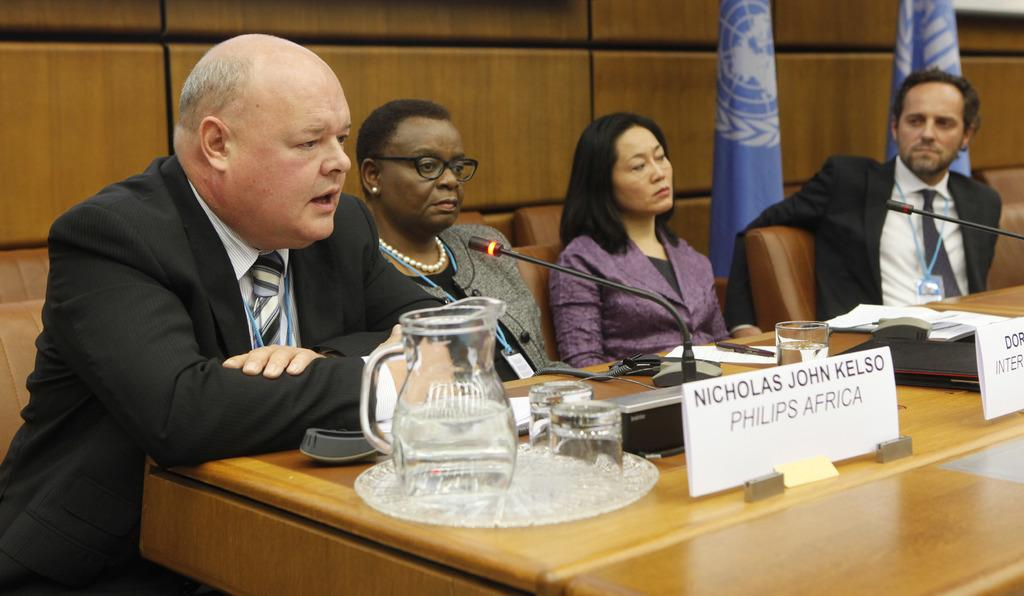What are the people in the image doing? The people in the image are sitting on chairs. Can you describe the table in the foreground of the image? There is a mug on a table in the foreground of the image. What type of coil is being used by the people in the image? There is no coil present in the image; the people are simply sitting on chairs. 